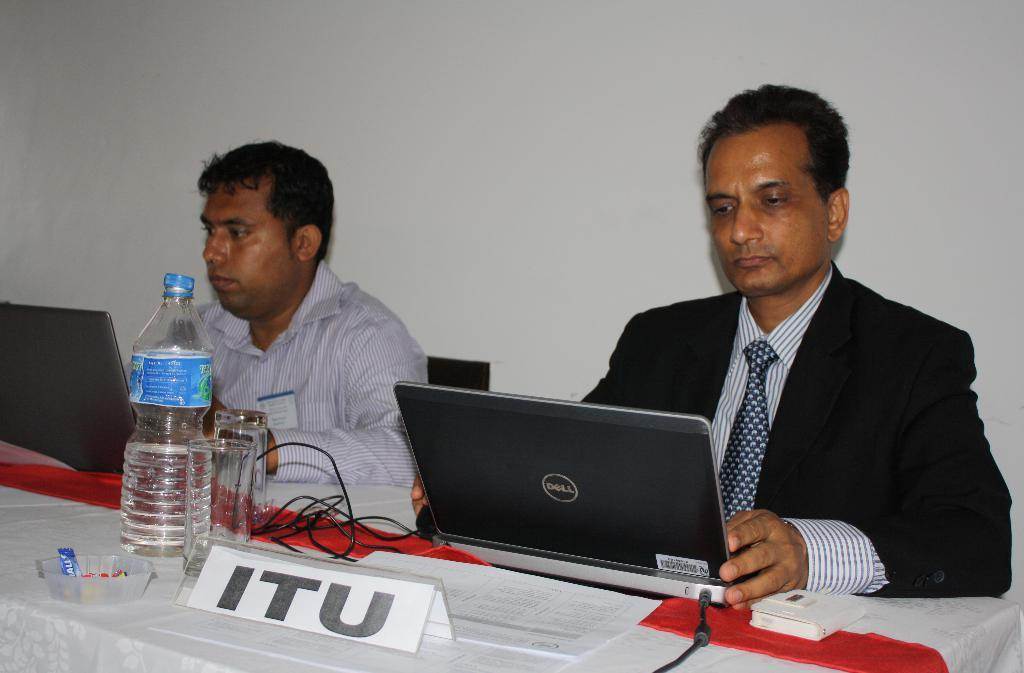Provide a one-sentence caption for the provided image. Representative of ITU on a laptop hard at work next to another person. 